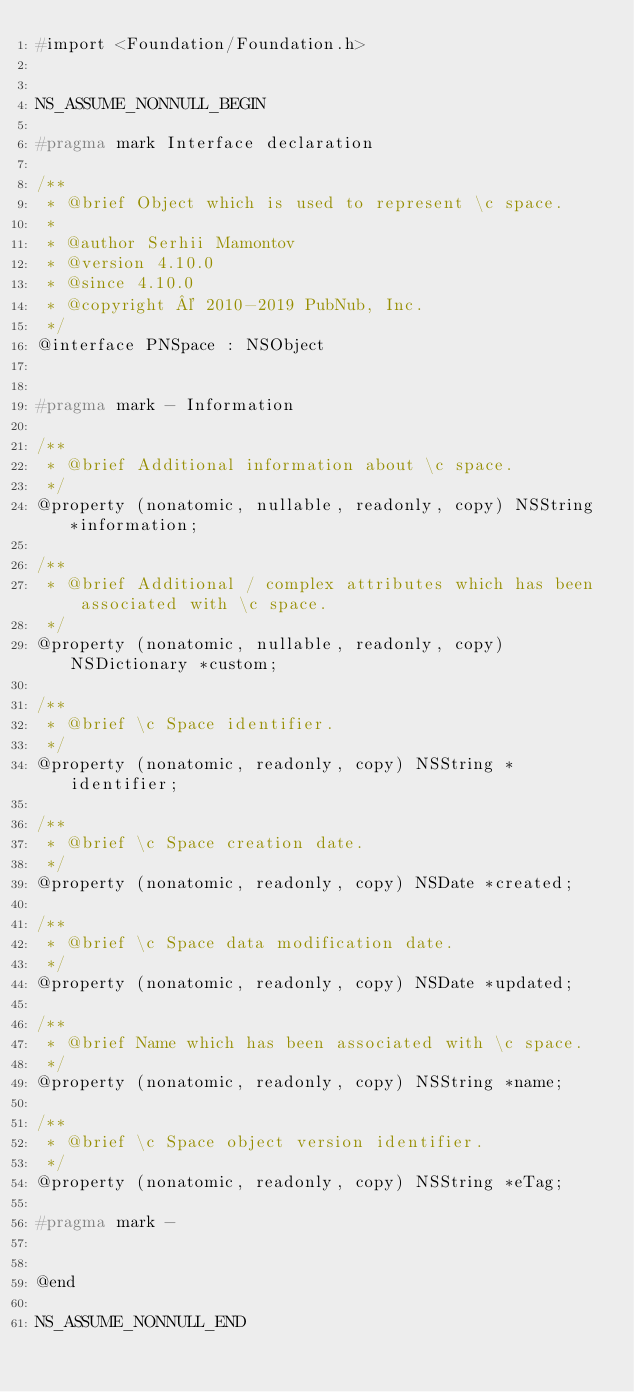Convert code to text. <code><loc_0><loc_0><loc_500><loc_500><_C_>#import <Foundation/Foundation.h>


NS_ASSUME_NONNULL_BEGIN

#pragma mark Interface declaration

/**
 * @brief Object which is used to represent \c space.
 *
 * @author Serhii Mamontov
 * @version 4.10.0
 * @since 4.10.0
 * @copyright © 2010-2019 PubNub, Inc.
 */
@interface PNSpace : NSObject


#pragma mark - Information

/**
 * @brief Additional information about \c space.
 */
@property (nonatomic, nullable, readonly, copy) NSString *information;

/**
 * @brief Additional / complex attributes which has been associated with \c space.
 */
@property (nonatomic, nullable, readonly, copy) NSDictionary *custom;

/**
 * @brief \c Space identifier.
 */
@property (nonatomic, readonly, copy) NSString *identifier;

/**
 * @brief \c Space creation date.
 */
@property (nonatomic, readonly, copy) NSDate *created;

/**
 * @brief \c Space data modification date.
 */
@property (nonatomic, readonly, copy) NSDate *updated;

/**
 * @brief Name which has been associated with \c space.
 */
@property (nonatomic, readonly, copy) NSString *name;

/**
 * @brief \c Space object version identifier.
 */
@property (nonatomic, readonly, copy) NSString *eTag;

#pragma mark -


@end

NS_ASSUME_NONNULL_END
</code> 